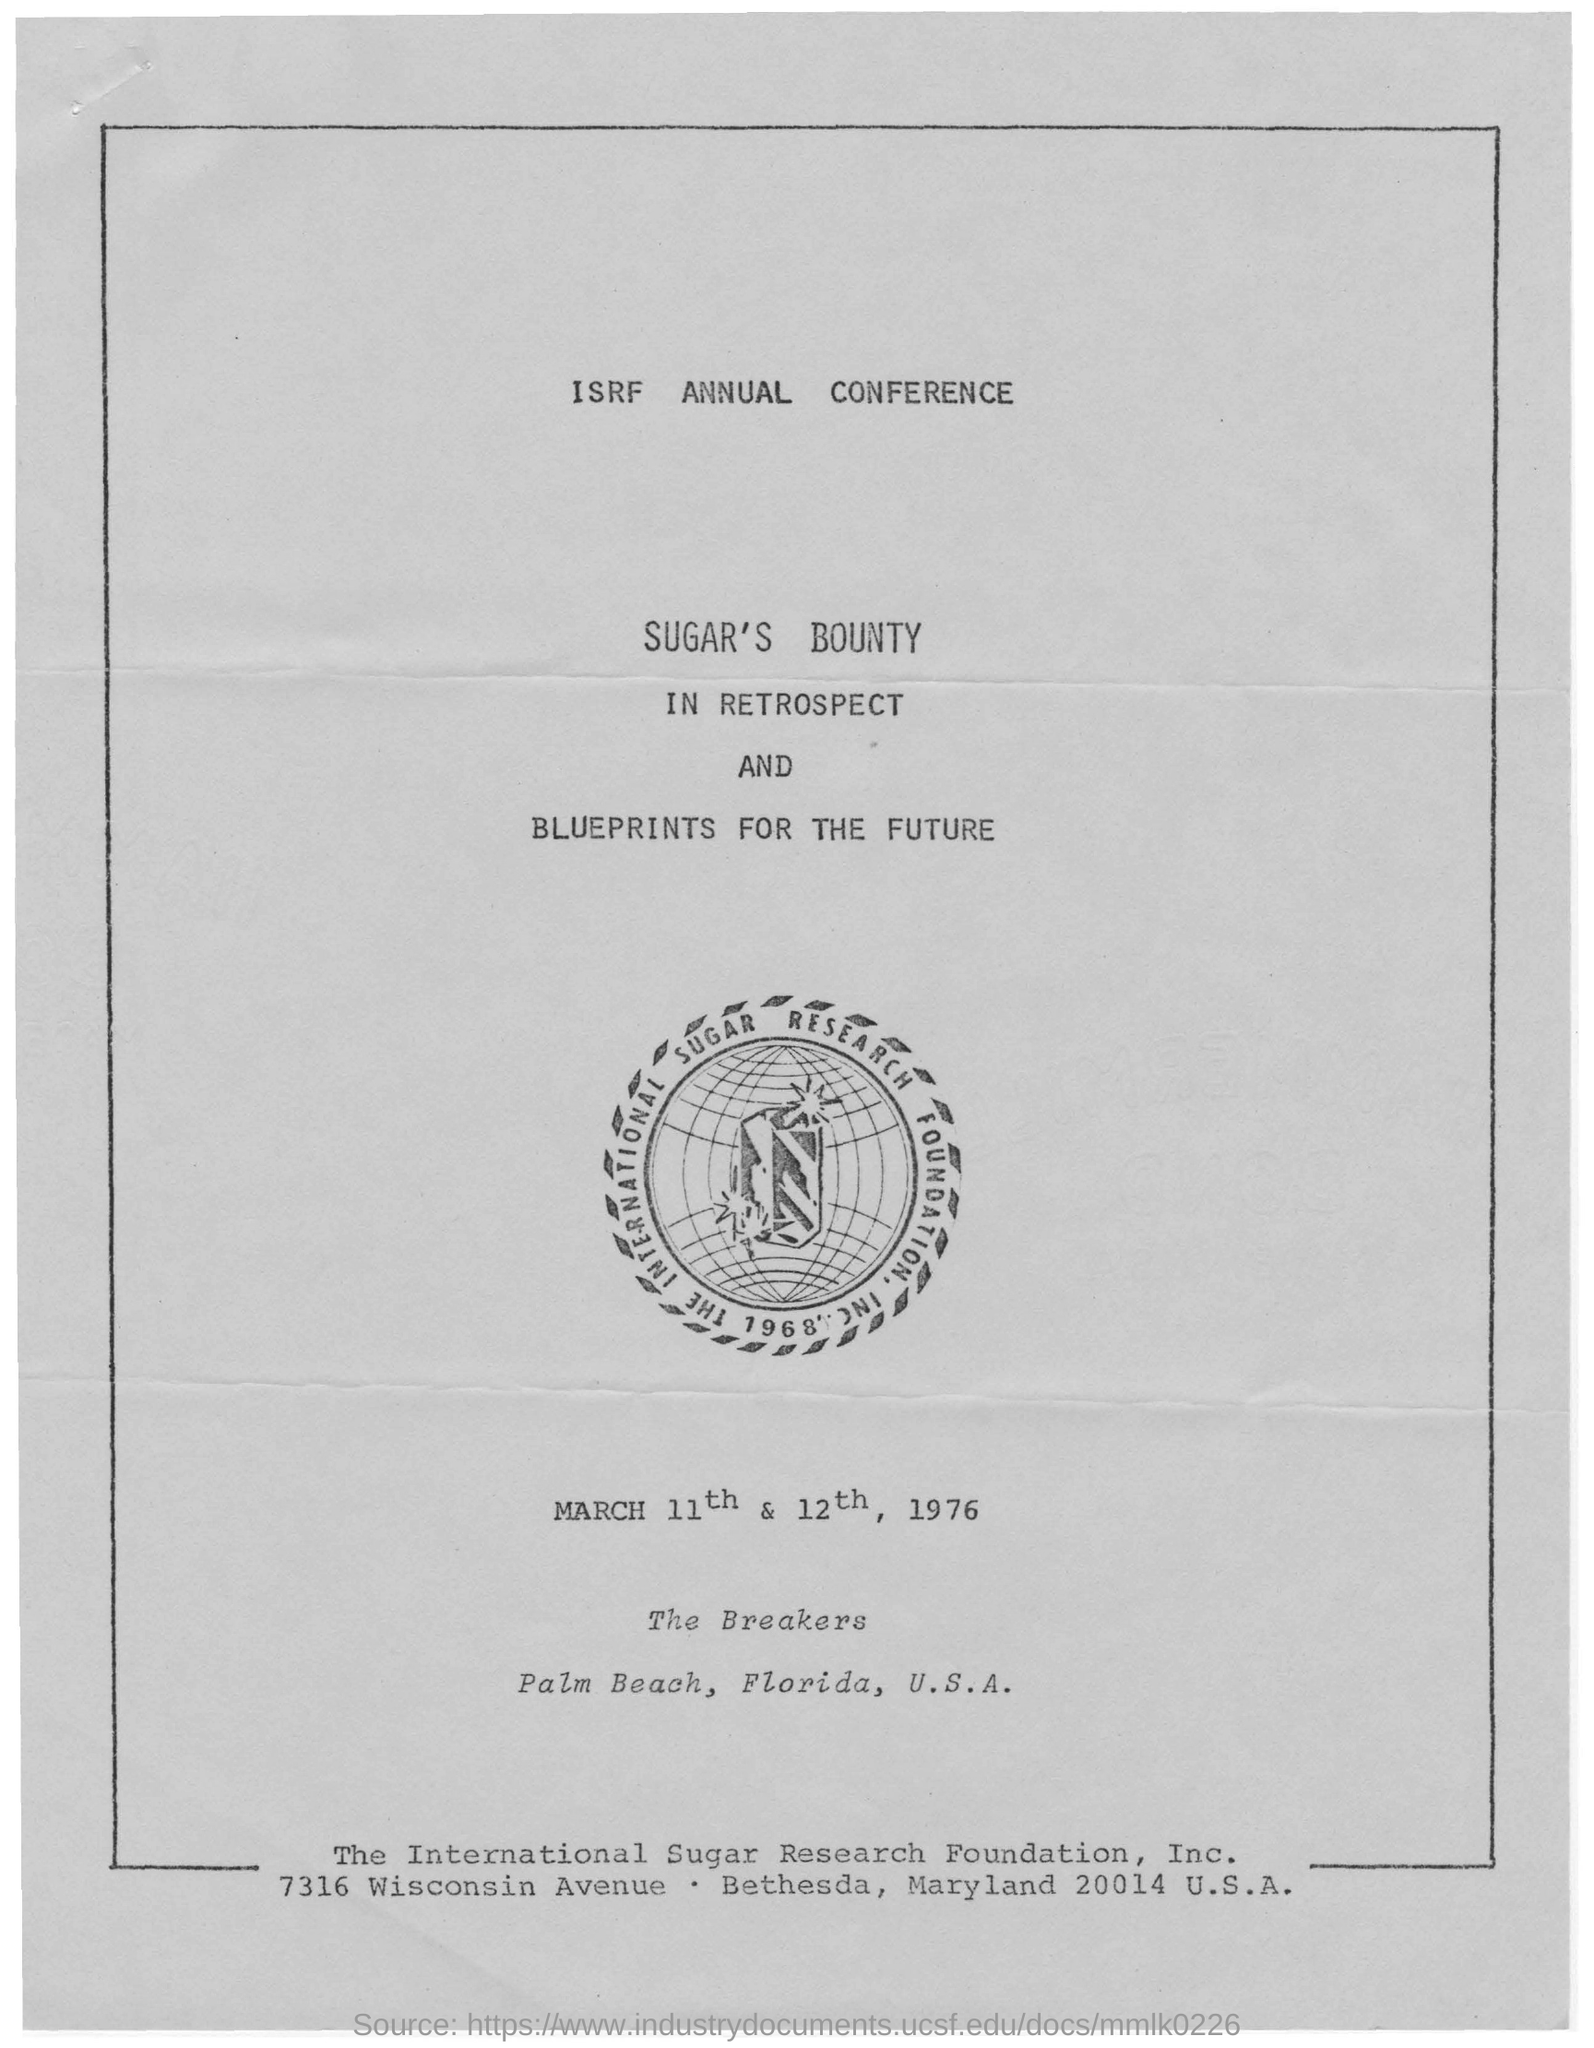What is the name of the conference ?
Make the answer very short. Isrf annual conference. On which dates and year this annual conference is held ?
Your answer should be compact. March 11th & 12th, 1976. On which topic this annual conference is held?
Give a very brief answer. Sugar's bounty in retrospect and blueprints for the future. What is the name of the foundation given ?
Ensure brevity in your answer.  The international sugar research foundation. 